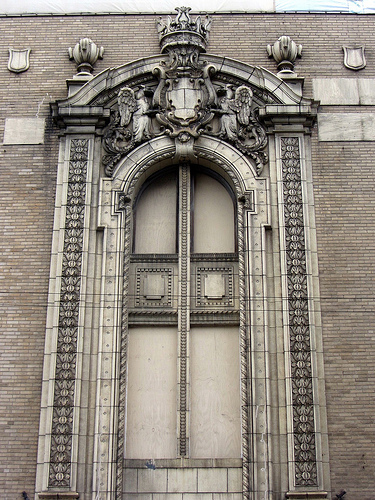<image>
Can you confirm if the wing is on the crown? No. The wing is not positioned on the crown. They may be near each other, but the wing is not supported by or resting on top of the crown. 